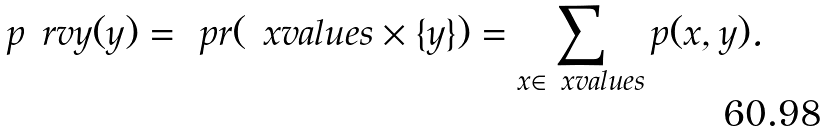Convert formula to latex. <formula><loc_0><loc_0><loc_500><loc_500>p _ { \ } r v y ( y ) = \ p r ( \ x v a l u e s \times \{ y \} ) = \sum _ { x \in \ x v a l u e s } p ( x , y ) .</formula> 